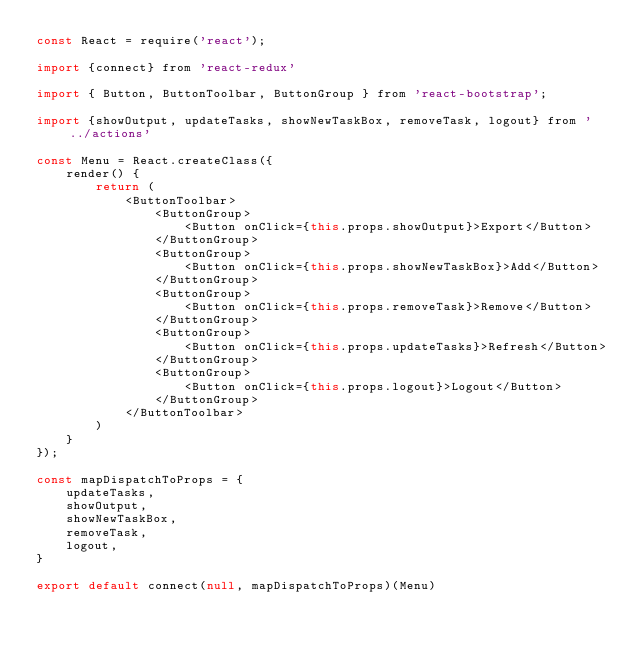Convert code to text. <code><loc_0><loc_0><loc_500><loc_500><_JavaScript_>const React = require('react');

import {connect} from 'react-redux'

import { Button, ButtonToolbar, ButtonGroup } from 'react-bootstrap';

import {showOutput, updateTasks, showNewTaskBox, removeTask, logout} from '../actions'

const Menu = React.createClass({
    render() {
        return (
            <ButtonToolbar>
                <ButtonGroup>
                    <Button onClick={this.props.showOutput}>Export</Button>
                </ButtonGroup>
                <ButtonGroup>
                    <Button onClick={this.props.showNewTaskBox}>Add</Button>
                </ButtonGroup>
                <ButtonGroup>
                    <Button onClick={this.props.removeTask}>Remove</Button>
                </ButtonGroup>
                <ButtonGroup>
                    <Button onClick={this.props.updateTasks}>Refresh</Button>
                </ButtonGroup>
                <ButtonGroup>
                    <Button onClick={this.props.logout}>Logout</Button>
                </ButtonGroup>
            </ButtonToolbar>
        )
    }
});

const mapDispatchToProps = {
    updateTasks,
    showOutput,
    showNewTaskBox,
    removeTask,
    logout,
}

export default connect(null, mapDispatchToProps)(Menu)


</code> 